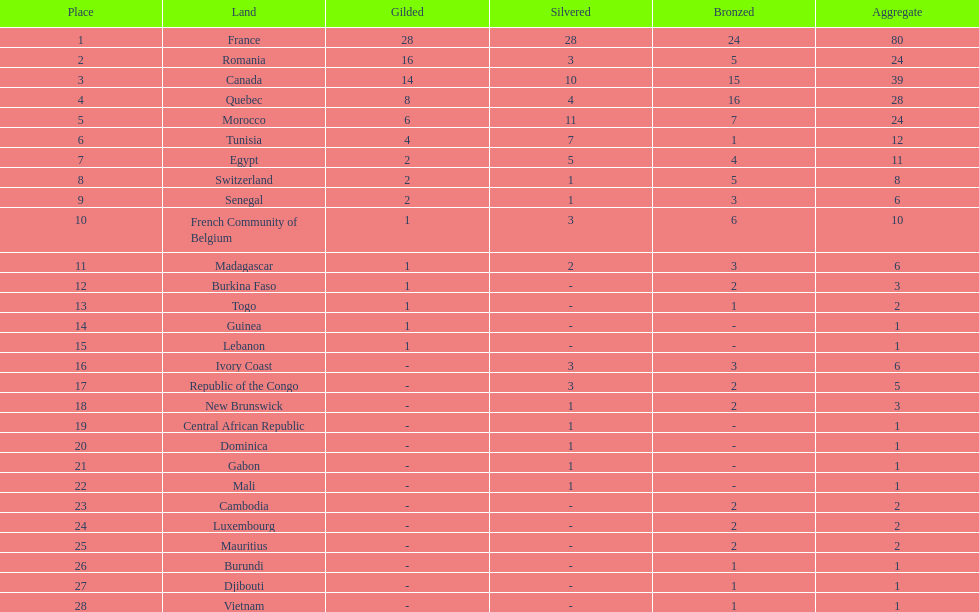What is the difference between france's and egypt's silver medals? 23. 